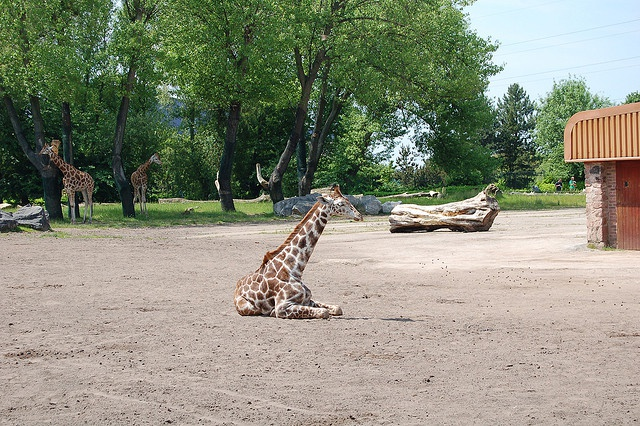Describe the objects in this image and their specific colors. I can see giraffe in olive, darkgray, lightgray, and gray tones, giraffe in olive, gray, black, and maroon tones, giraffe in olive, gray, and black tones, people in olive, black, gray, and darkgreen tones, and people in olive, teal, turquoise, gray, and darkgray tones in this image. 